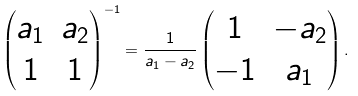Convert formula to latex. <formula><loc_0><loc_0><loc_500><loc_500>\begin{pmatrix} a _ { 1 } & a _ { 2 } \\ 1 & 1 \end{pmatrix} ^ { - 1 } = \frac { 1 } { a _ { 1 } - a _ { 2 } } \begin{pmatrix} 1 & - a _ { 2 } \\ - 1 & a _ { 1 } \end{pmatrix} .</formula> 